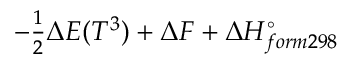<formula> <loc_0><loc_0><loc_500><loc_500>- \frac { 1 } { 2 } \Delta E ( T ^ { 3 } ) + \Delta F + \Delta H _ { f o r m 2 9 8 } ^ { \circ }</formula> 